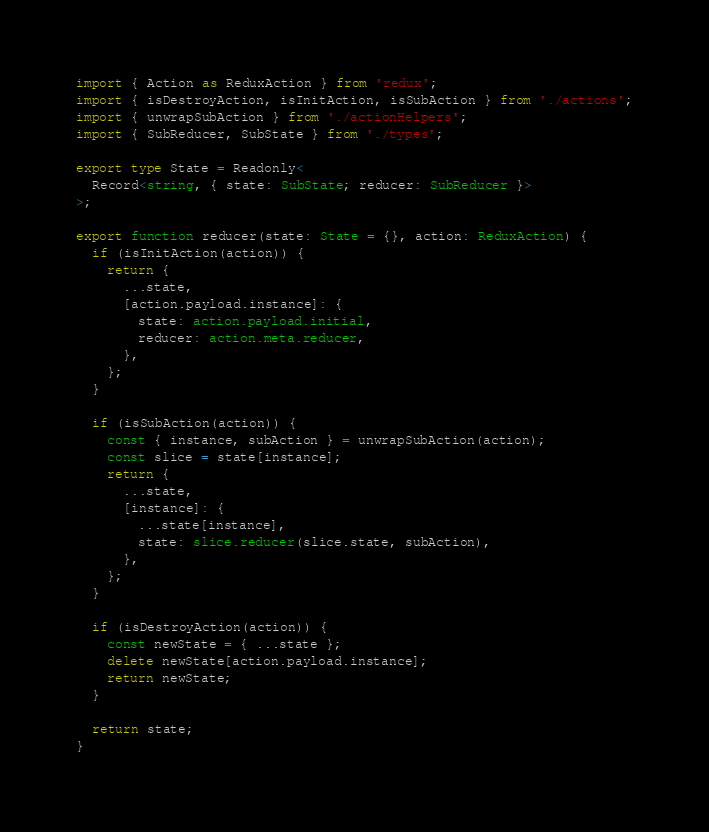Convert code to text. <code><loc_0><loc_0><loc_500><loc_500><_TypeScript_>import { Action as ReduxAction } from 'redux';
import { isDestroyAction, isInitAction, isSubAction } from './actions';
import { unwrapSubAction } from './actionHelpers';
import { SubReducer, SubState } from './types';

export type State = Readonly<
  Record<string, { state: SubState; reducer: SubReducer }>
>;

export function reducer(state: State = {}, action: ReduxAction) {
  if (isInitAction(action)) {
    return {
      ...state,
      [action.payload.instance]: {
        state: action.payload.initial,
        reducer: action.meta.reducer,
      },
    };
  }

  if (isSubAction(action)) {
    const { instance, subAction } = unwrapSubAction(action);
    const slice = state[instance];
    return {
      ...state,
      [instance]: {
        ...state[instance],
        state: slice.reducer(slice.state, subAction),
      },
    };
  }

  if (isDestroyAction(action)) {
    const newState = { ...state };
    delete newState[action.payload.instance];
    return newState;
  }

  return state;
}
</code> 